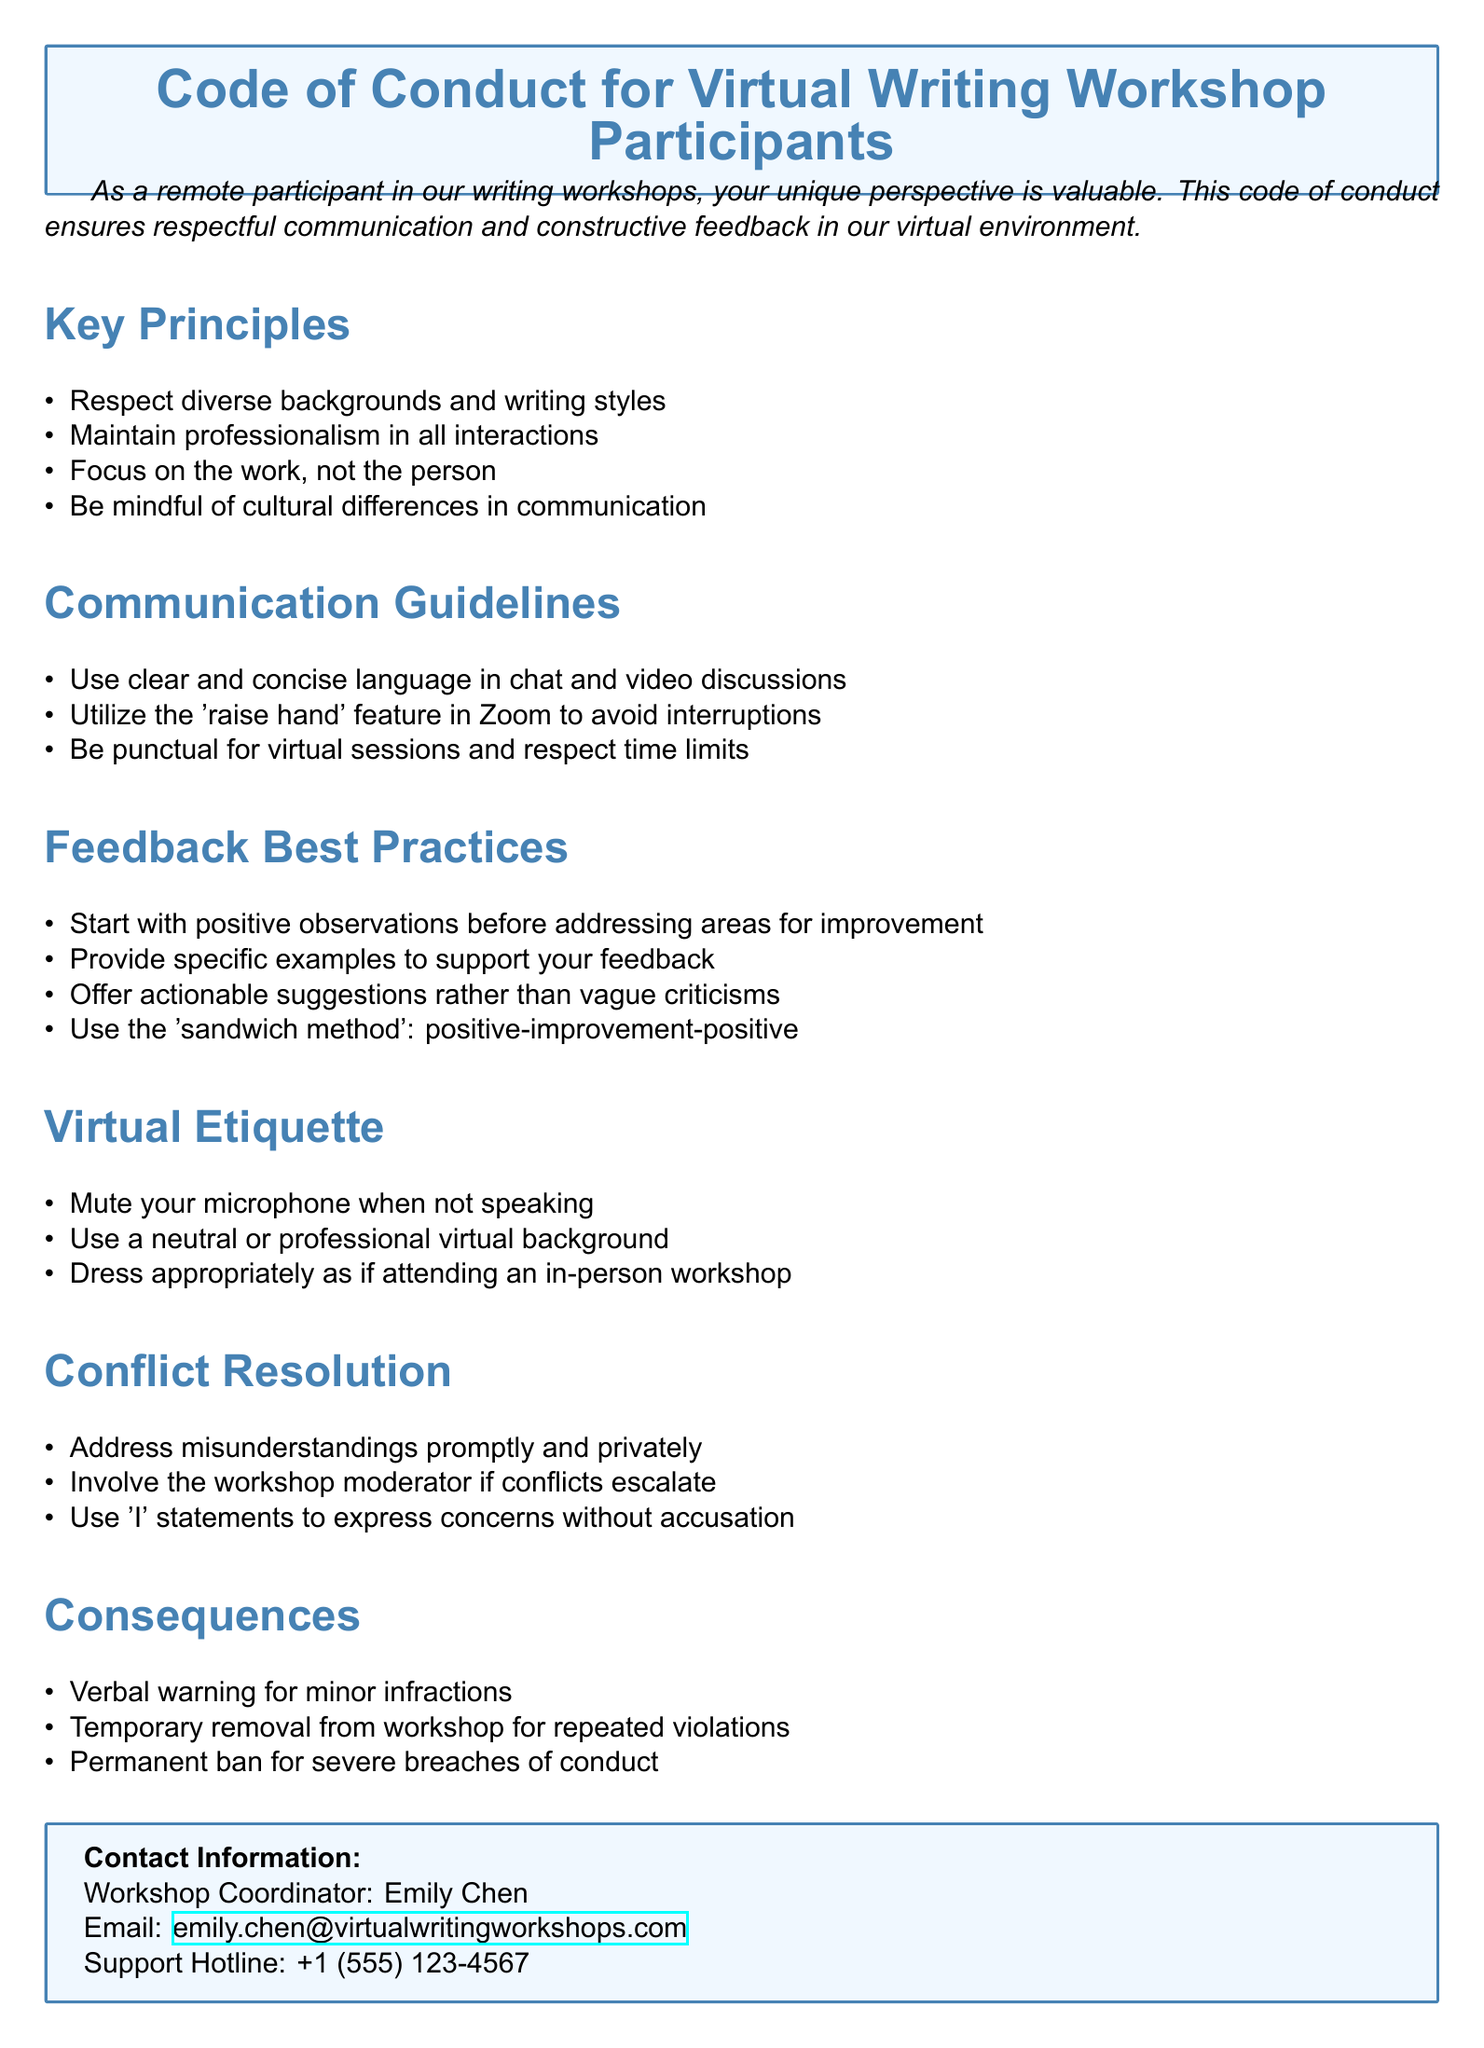What is the title of the document? The title is clearly stated at the beginning of the document in a box, which outlines the purpose of the document.
Answer: Code of Conduct for Virtual Writing Workshop Participants Who is the workshop coordinator? The document provides contact information specifically naming the workshop coordinator.
Answer: Emily Chen What should participants start with when giving feedback? The feedback best practices section outlines the initial approach for providing feedback, indicating what should be prioritized.
Answer: Positive observations How should participants address misunderstandings? The conflict resolution section specifies how misunderstandings should be handled among participants.
Answer: Promptly and privately What is the consequence for severe breaches of conduct? One specific consequence is listed in the document regarding actions taken for severe breaches of the code.
Answer: Permanent ban How many principles are listed under Key Principles? The document lists specific principles that outline the code of conduct for participants.
Answer: Four What method is recommended for providing feedback? The feedback section presents a specific approach to giving constructive feedback, which is a commonly recognized strategy.
Answer: Sandwich method What should you do with your microphone when not speaking? The etiquette section provides a guideline for virtual communication regarding microphone use.
Answer: Mute your microphone 